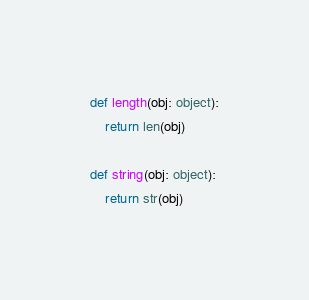Convert code to text. <code><loc_0><loc_0><loc_500><loc_500><_Python_>def length(obj: object):
	return len(obj)

def string(obj: object):
	return str(obj)</code> 